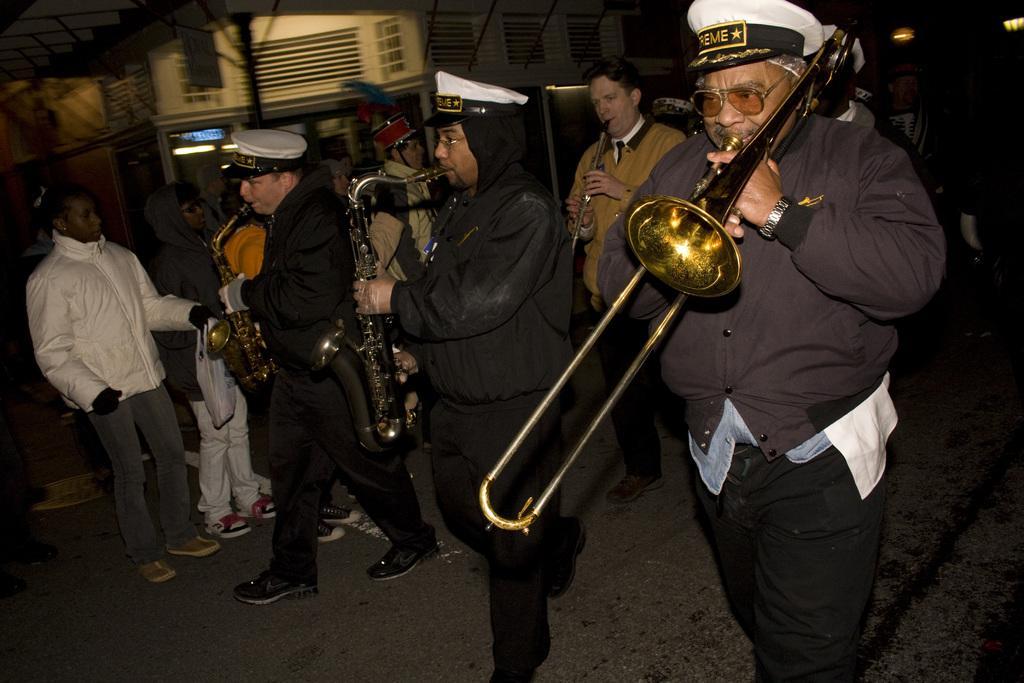Could you give a brief overview of what you see in this image? In this image in the center there are persons playing musical instrument. On the left side there are persons standing. In the background there is a building and there is a pole. 